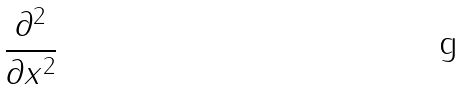<formula> <loc_0><loc_0><loc_500><loc_500>\frac { \partial ^ { 2 } } { \partial x ^ { 2 } }</formula> 